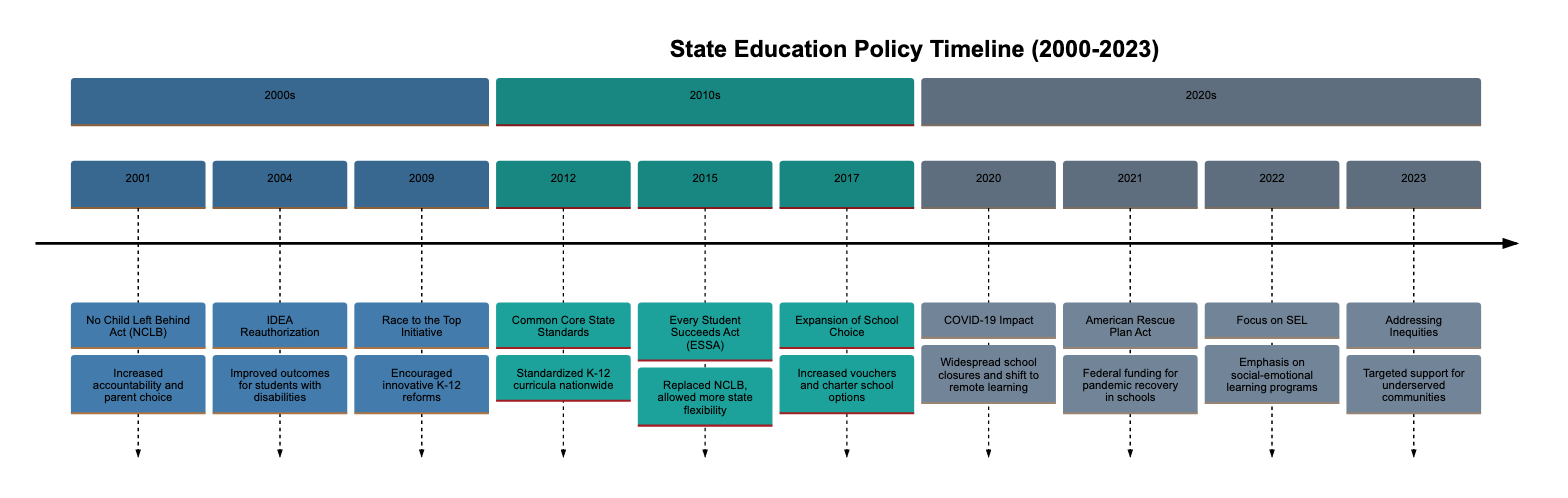What major federal law was introduced in 2001? The diagram indicates that the No Child Left Behind Act (NCLB) was enacted in 2001. This is located in the section for the 2000s, where NCLB is labeled as a key event.
Answer: No Child Left Behind Act In which year did the Race to the Top Initiative occur? According to the timeline, the Race to the Top Initiative took place in 2009, as it is marked specifically in that year in the 2000s section.
Answer: 2009 What significant education reform was implemented in 2015? The timeline shows that the Every Student Succeeds Act (ESSA) replaced NCLB in 2015, making it a significant policy change during that year in the 2010s section.
Answer: Every Student Succeeds Act Which policy emphasized social-emotional learning in 2022? In 2022, the timeline highlights a focus on Social-Emotional Learning (SEL), making it the specific initiative for that year shown in the 2020s section.
Answer: Focus on Social-Emotional Learning What was a key outcome of the American Rescue Plan Act in 2021? The diagram mentions that the American Rescue Plan Act provided federal funding to help schools recover from the disruptions caused by the pandemic in 2021. Therefore, its primary outcome was the financial support for recovery efforts.
Answer: Federal funding for pandemic recovery How did the introduction of Common Core in 2012 impact educational standards? The diagram indicates that the Common Core State Standards Initiative aimed to standardize K-12 curricula across states in 2012, thereby impacting educational consistency and expectations nationwide.
Answer: Standardized K-12 curricula What was the focus of education policies in 2023? The timeline shows that in 2023, the focus was on addressing educational inequities, highlighting how states increasingly directed their policies to close opportunity gaps.
Answer: Addressing Educational Inequities Which event led to a shift to remote learning? The timeline clearly states that the impact of COVID-19 in 2020 resulted in widespread school closures, leading to a rapid transition to remote learning. Thus, COVID-19 is the event responsible for this shift.
Answer: COVID-19 Impact What year did the expansion of school choice programs occur, and which administration encouraged it? The timeline states that the expansion of school choice programs took place in 2017 and was encouraged by the Trump administration, reflecting a policy direction during that year.
Answer: 2017, Trump administration 